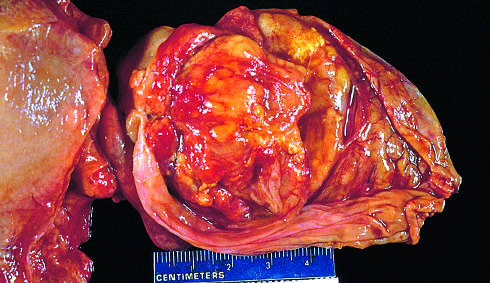what does the opened gallbladder contain?
Answer the question using a single word or phrase. A large 